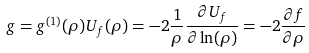Convert formula to latex. <formula><loc_0><loc_0><loc_500><loc_500>g = g ^ { ( 1 ) } ( \rho ) U _ { f } ( \rho ) = - 2 \frac { 1 } { \rho } \frac { \partial U _ { f } } { \partial \ln ( \rho ) } = - 2 \frac { \partial f } { \partial \rho }</formula> 